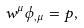Convert formula to latex. <formula><loc_0><loc_0><loc_500><loc_500>w ^ { \mu } \phi _ { , \mu } = p ,</formula> 